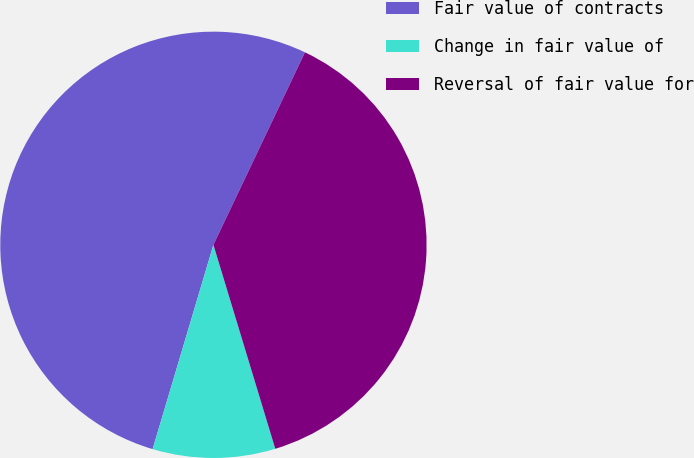Convert chart. <chart><loc_0><loc_0><loc_500><loc_500><pie_chart><fcel>Fair value of contracts<fcel>Change in fair value of<fcel>Reversal of fair value for<nl><fcel>52.46%<fcel>9.29%<fcel>38.25%<nl></chart> 